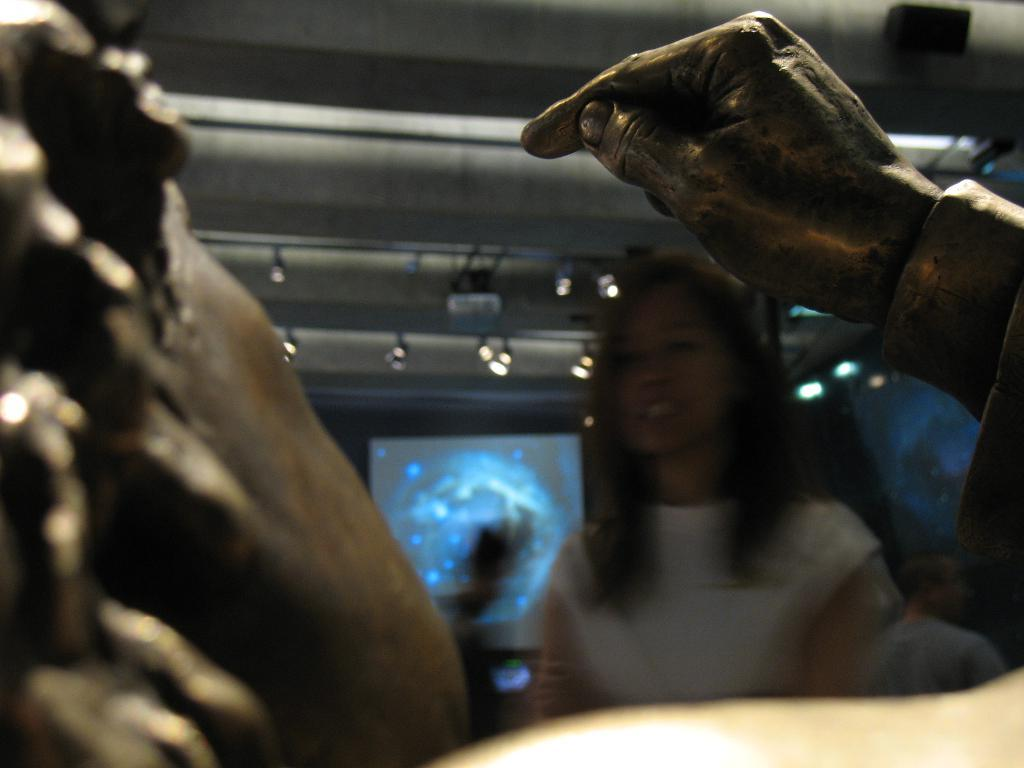What is shown in the image that represents a part of the human body? There is a depiction of a person's hand in the image. Can you describe the woman in the image? There is a woman wearing a white top in the image. What can be seen in the background of the image? There is a display screen and lights visible in the background of the image. What type of seed is the woman planting in the image? There is no seed or planting activity depicted in the image; it features a woman wearing a white top and a depiction of a hand. Who is coaching the woman in the image? There is no coach or coaching activity depicted in the image; it only shows a woman wearing a white top and a hand. 